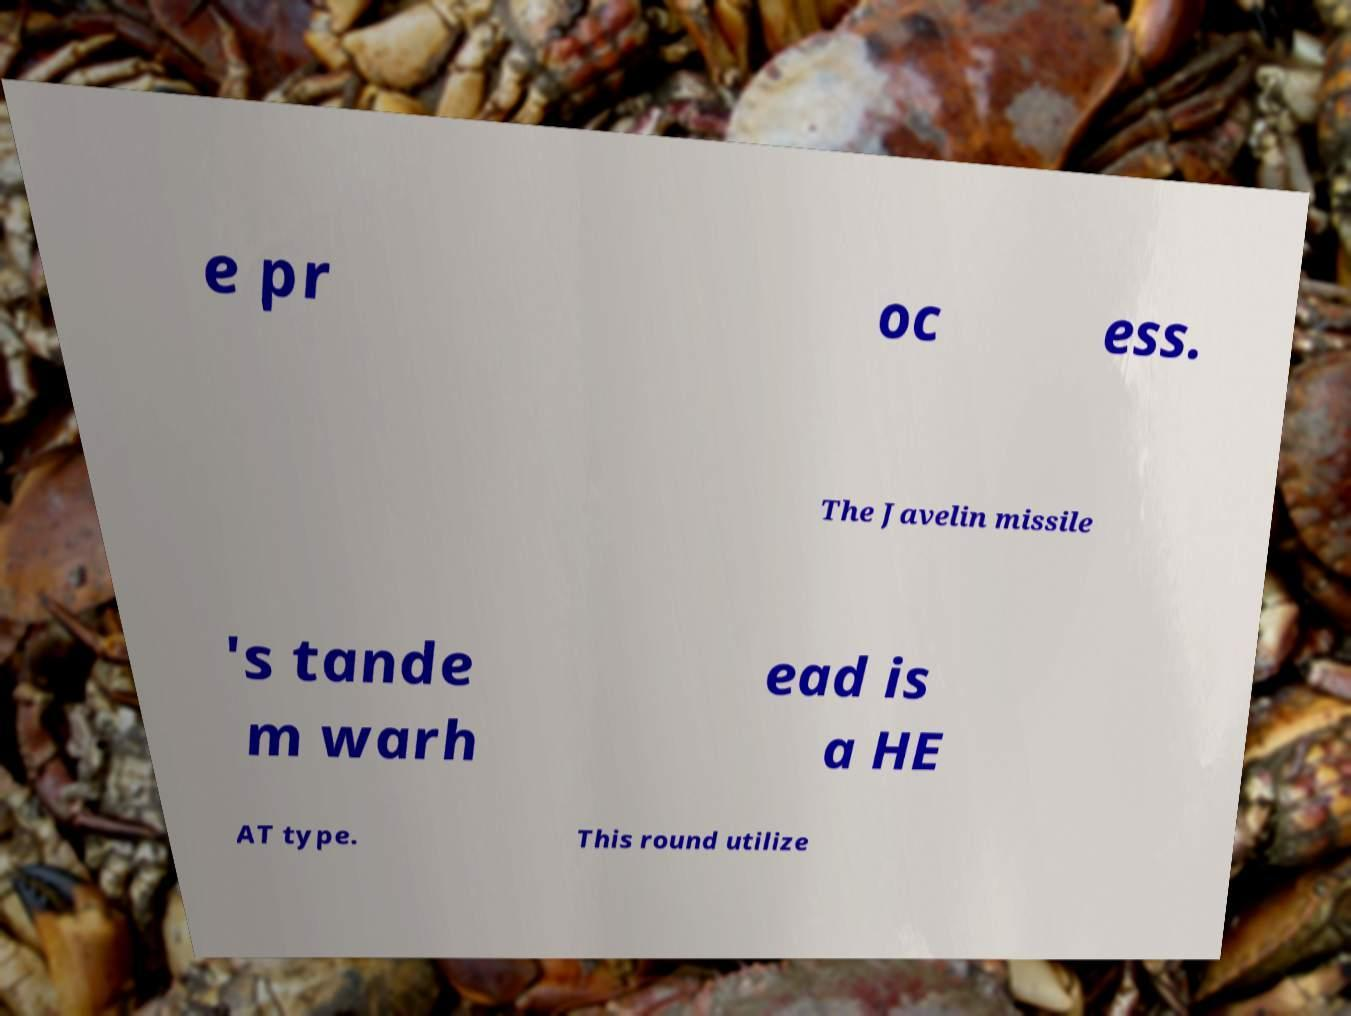What messages or text are displayed in this image? I need them in a readable, typed format. e pr oc ess. The Javelin missile 's tande m warh ead is a HE AT type. This round utilize 